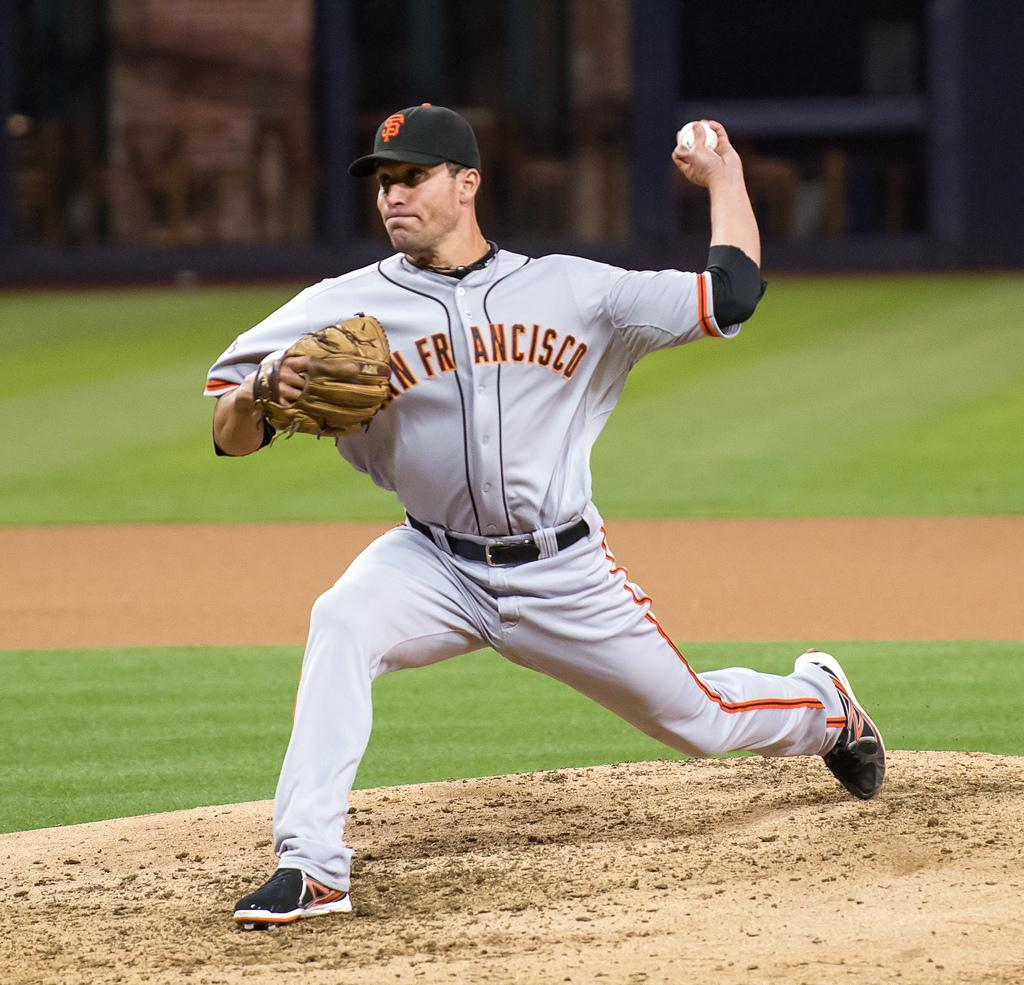<image>
Provide a brief description of the given image. A pitcher in a San Francisco uniform gets ready to throw the ball. 